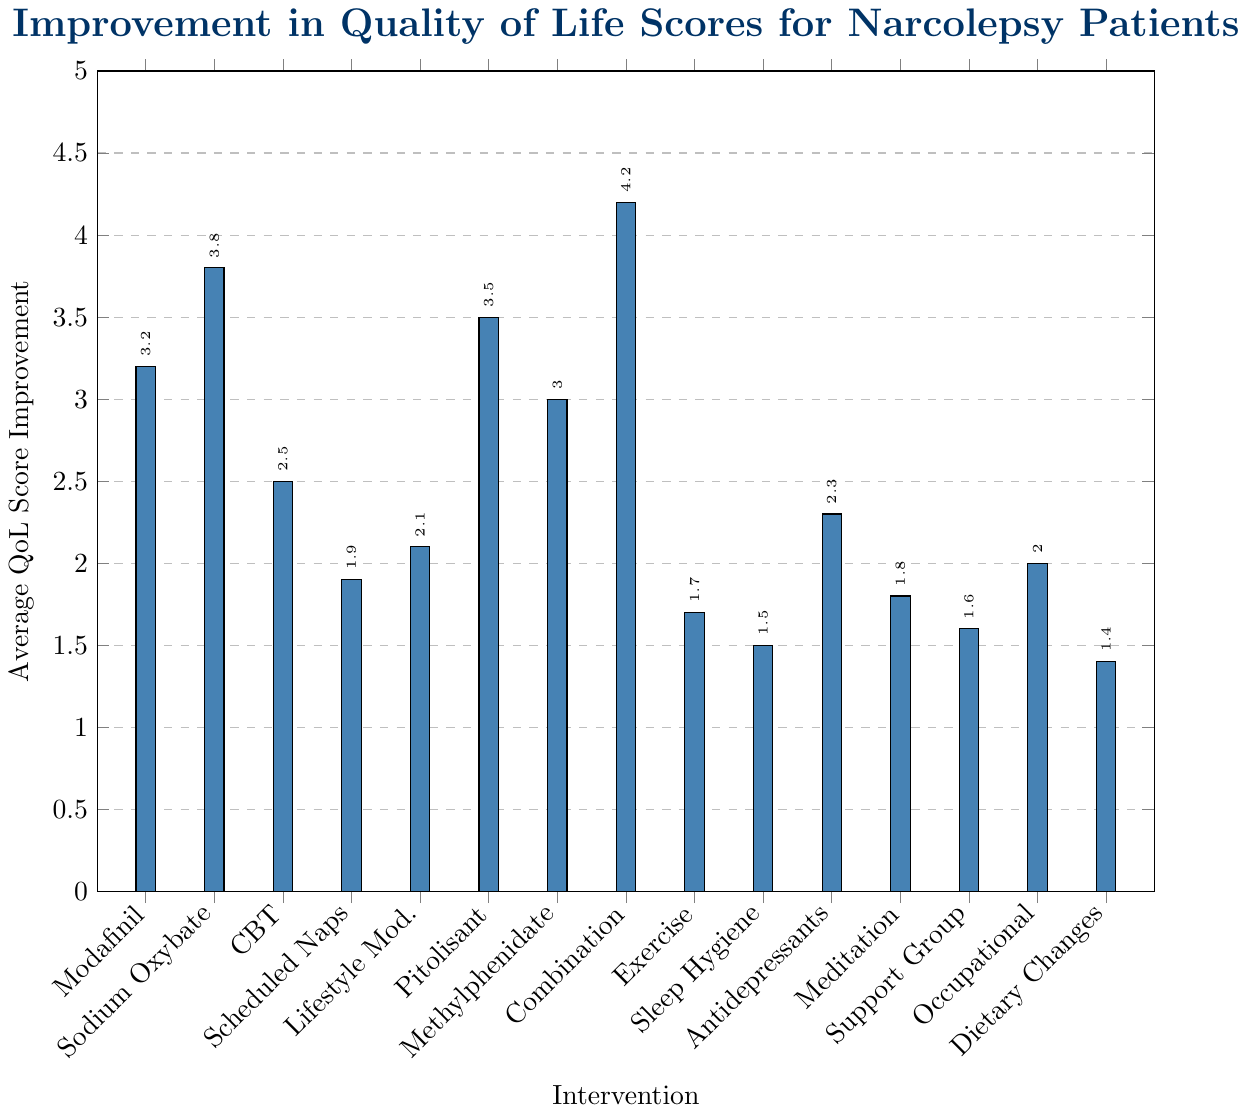What intervention shows the highest average QoL score improvement? By looking at the height of the bars, the tallest bar corresponds to the "Combination Therapy (Modafinil + Sodium Oxybate)" intervention.
Answer: Combination Therapy (Modafinil + Sodium Oxybate) Which intervention has a lower QoL improvement, Scheduled Naps or Exercise Program? By comparing the height of the bars for "Scheduled Naps" and "Exercise Program", the bar for "Scheduled Naps" is higher than the bar for "Exercise Program".
Answer: Exercise Program What's the difference in QoL score improvement between Sodium Oxybate Therapy and Cognitive Behavioral Therapy (CBT)? The average QoL score improvement for Sodium Oxybate Therapy is 3.8 and for CBT it is 2.5. The difference is calculated as 3.8 - 2.5.
Answer: 1.3 Which interventions have an average QoL score improvement greater than 3.0? By looking at the bars taller than 3.0, the interventions are "Sodium Oxybate Therapy", "Pitolisant Treatment", "Combination Therapy (Modafinil + Sodium Oxybate)", "Modafinil Treatment", and "Methylphenidate Treatment".
Answer: Sodium Oxybate Therapy, Pitolisant Treatment, Combination Therapy (Modafinil + Sodium Oxybate), Modafinil Treatment, Methylphenidate Treatment How many interventions have an average QoL score improvement of 2.0 or higher? Count the bars that reach or exceed the height of 2.0 on the y-axis. These are "Modafinil Treatment", "Sodium Oxybate Therapy", "Cognitive Behavioral Therapy", "Lifestyle Modifications", "Pitolisant Treatment", "Methylphenidate Treatment", "Combination Therapy", "Antidepressant Therapy", and "Occupational Therapy". There are 9 interventions in total.
Answer: 9 What's the sum of the average QoL score improvements for the Exercise Program and Sleep Hygiene Education? The average QoL score improvements are 1.7 for Exercise Program and 1.5 for Sleep Hygiene Education. Summing them gives 1.7 + 1.5.
Answer: 3.2 Which has a greater QoL score improvement: Mindfulness Meditation or Support Group Participation? By comparing the height of the bars, the bar for "Mindfulness Meditation" is higher than the bar for "Support Group Participation".
Answer: Mindfulness Meditation What's the average QoL score improvement across all interventions? Sum all improvement values: 3.2 + 3.8 + 2.5 + 1.9 + 2.1 + 3.5 + 3.0 + 4.2 + 1.7 + 1.5 + 2.3 + 1.8 + 1.6 + 2.0 + 1.4 = 38.5. There are 15 interventions, so the average is 38.5 / 15.
Answer: 2.57 